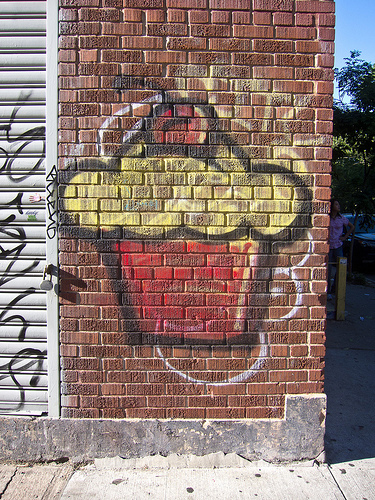<image>
Is there a cupcake on the brick wall? Yes. Looking at the image, I can see the cupcake is positioned on top of the brick wall, with the brick wall providing support. Where is the cupcake in relation to the wall? Is it on the wall? Yes. Looking at the image, I can see the cupcake is positioned on top of the wall, with the wall providing support. 